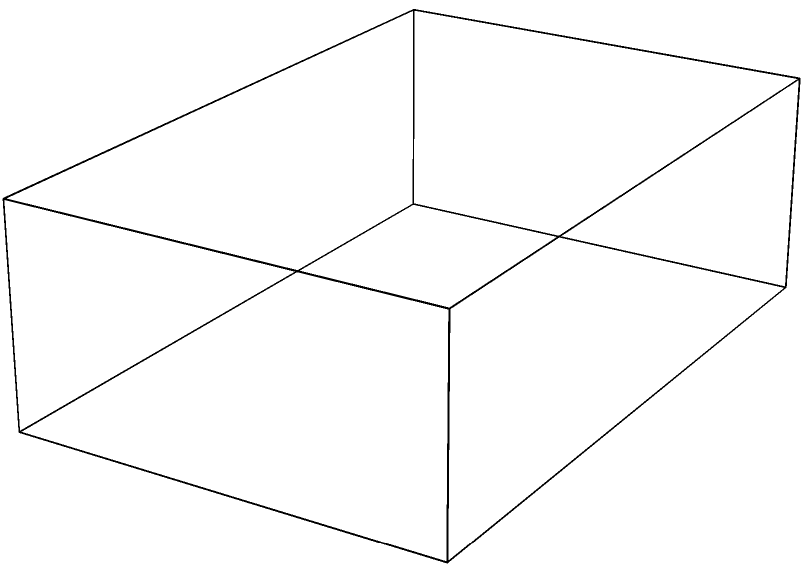In a film production, you're given a 2D storyboard (shown on the left) for a scene. The director wants to emphasize the artificiality of beauty standards by creating a surreal set. How would you translate this storyboard into a 3D scene layout (shown on the right) to critique societal obsession with perfection? To translate the 2D storyboard into a 3D scene layout while critiquing beauty standards, follow these steps:

1. Interpret the 2D shapes:
   - Rectangle → 3D box (room or stage)
   - Circle → Sphere (representing idealized beauty)
   - Vertical rectangle → Cylinder (mirror or pedestal)

2. Place elements in 3D space:
   - Box: Forms the base of the scene, representing societal constraints
   - Sphere: Positioned slightly above the box, symbolizing unattainable perfection
   - Cylinder: Placed upright, representing the constant scrutiny in pageants

3. Consider symbolism:
   - Box: Rigid beauty standards confining individuals
   - Sphere: Impossibly perfect, floating above reality
   - Cylinder: Mirrors or pedestals that objectify contestants

4. Emphasize artificiality:
   - Use unrealistic proportions (e.g., oversized sphere)
   - Employ stark, unnatural lighting to highlight imperfections
   - Incorporate reflective surfaces to show distorted self-images

5. Create visual tension:
   - Position elements slightly off-center to create unease
   - Use contrasting sizes to show the disconnect between expectations and reality

By translating the 2D storyboard into this surreal 3D layout, the scene visually critiques the shallow nature of beauty pageants and the harmful standards they promote, aligning with the film critic's perspective.
Answer: Surreal 3D layout with exaggerated proportions and symbolic placement of elements 